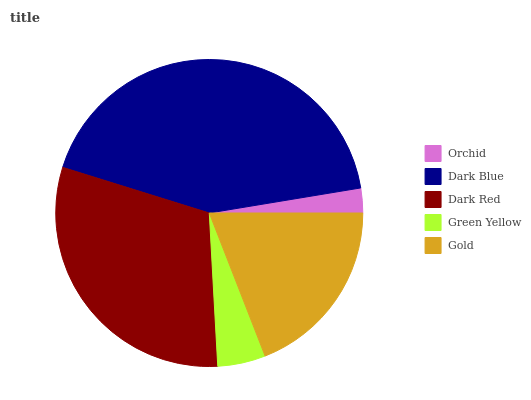Is Orchid the minimum?
Answer yes or no. Yes. Is Dark Blue the maximum?
Answer yes or no. Yes. Is Dark Red the minimum?
Answer yes or no. No. Is Dark Red the maximum?
Answer yes or no. No. Is Dark Blue greater than Dark Red?
Answer yes or no. Yes. Is Dark Red less than Dark Blue?
Answer yes or no. Yes. Is Dark Red greater than Dark Blue?
Answer yes or no. No. Is Dark Blue less than Dark Red?
Answer yes or no. No. Is Gold the high median?
Answer yes or no. Yes. Is Gold the low median?
Answer yes or no. Yes. Is Orchid the high median?
Answer yes or no. No. Is Dark Blue the low median?
Answer yes or no. No. 